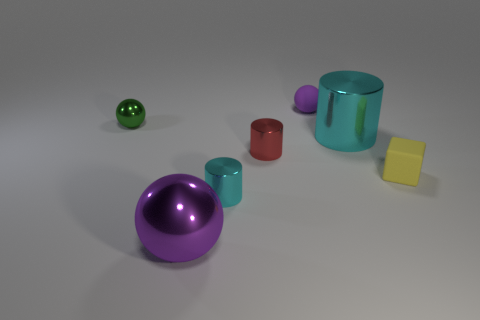Can you describe the lighting in this scene? The scene is softly lit with diffused lighting, which appears to come from above and slightly to the right, based on the shadows and highlights on the objects. This creates a gentle contrast and gives the objects a three-dimensional appearance. 